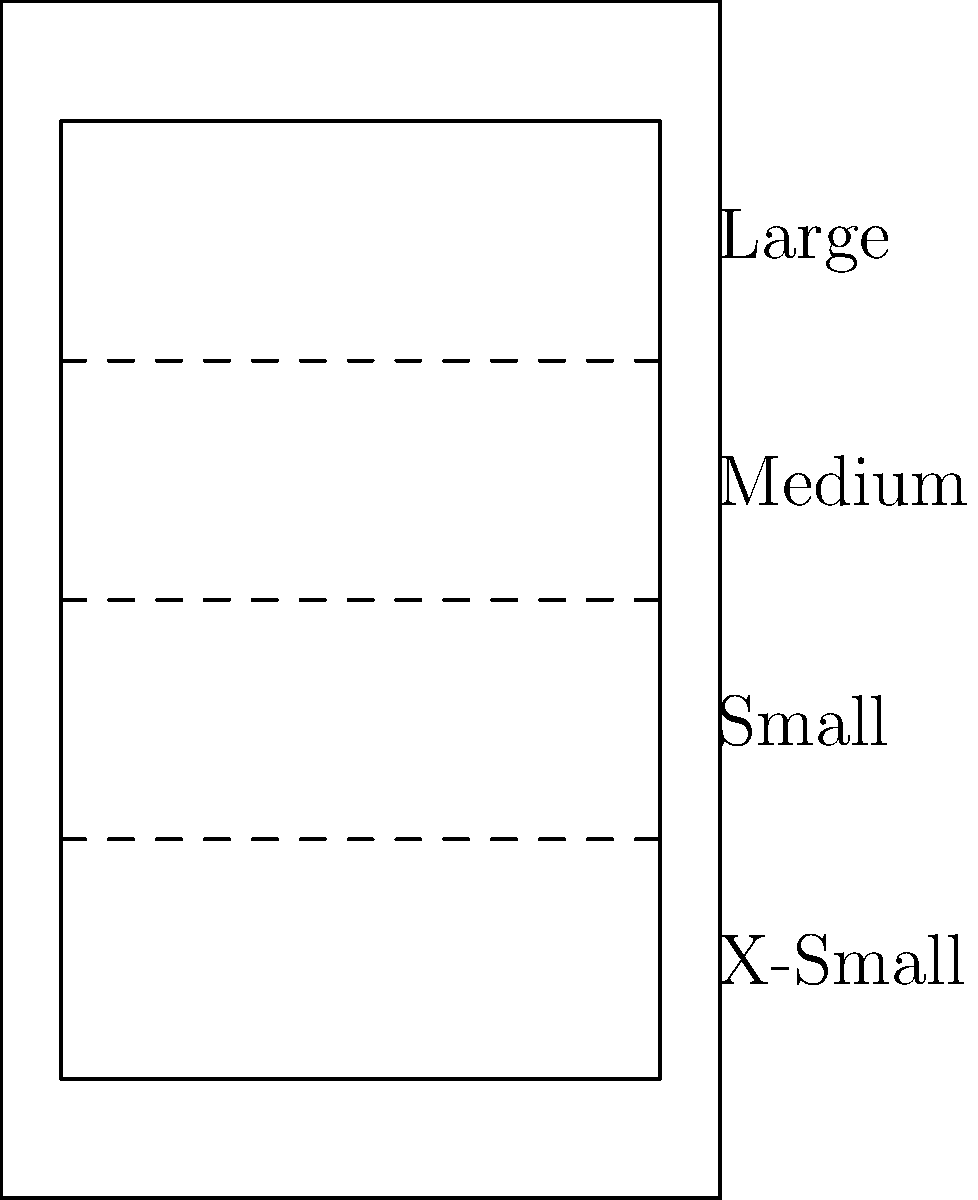In the mobile device mockup above, how many responsive design breakpoints are illustrated, and what does each horizontal dashed line represent in terms of screen size adaptation? To answer this question, let's analyze the image step-by-step:

1. The image shows a simplified mobile device mockup with a screen area.

2. Within the screen area, we can see three horizontal dashed lines.

3. Each dashed line represents a breakpoint in responsive web design. Breakpoints are specific screen widths where the layout of a website changes to accommodate different device sizes.

4. The dashed lines divide the screen into four sections, labeled from top to bottom as:
   - Large
   - Medium
   - Small
   - X-Small

5. These labels correspond to common responsive design categories, typically used to define different layout behaviors for various screen sizes.

6. The three dashed lines represent the transitions between these four categories, i.e., the points at which the layout would change as the screen size decreases.

Therefore, the image illustrates 3 breakpoints, each represented by a dashed line. These breakpoints define the transitions between Large and Medium, Medium and Small, and Small and X-Small screen sizes, allowing for adaptive layouts in responsive web design.
Answer: 3 breakpoints; transitions between screen size categories 